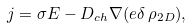<formula> <loc_0><loc_0><loc_500><loc_500>j = \sigma E - D _ { c h } \nabla ( e \delta \, \rho _ { 2 D } ) ,</formula> 